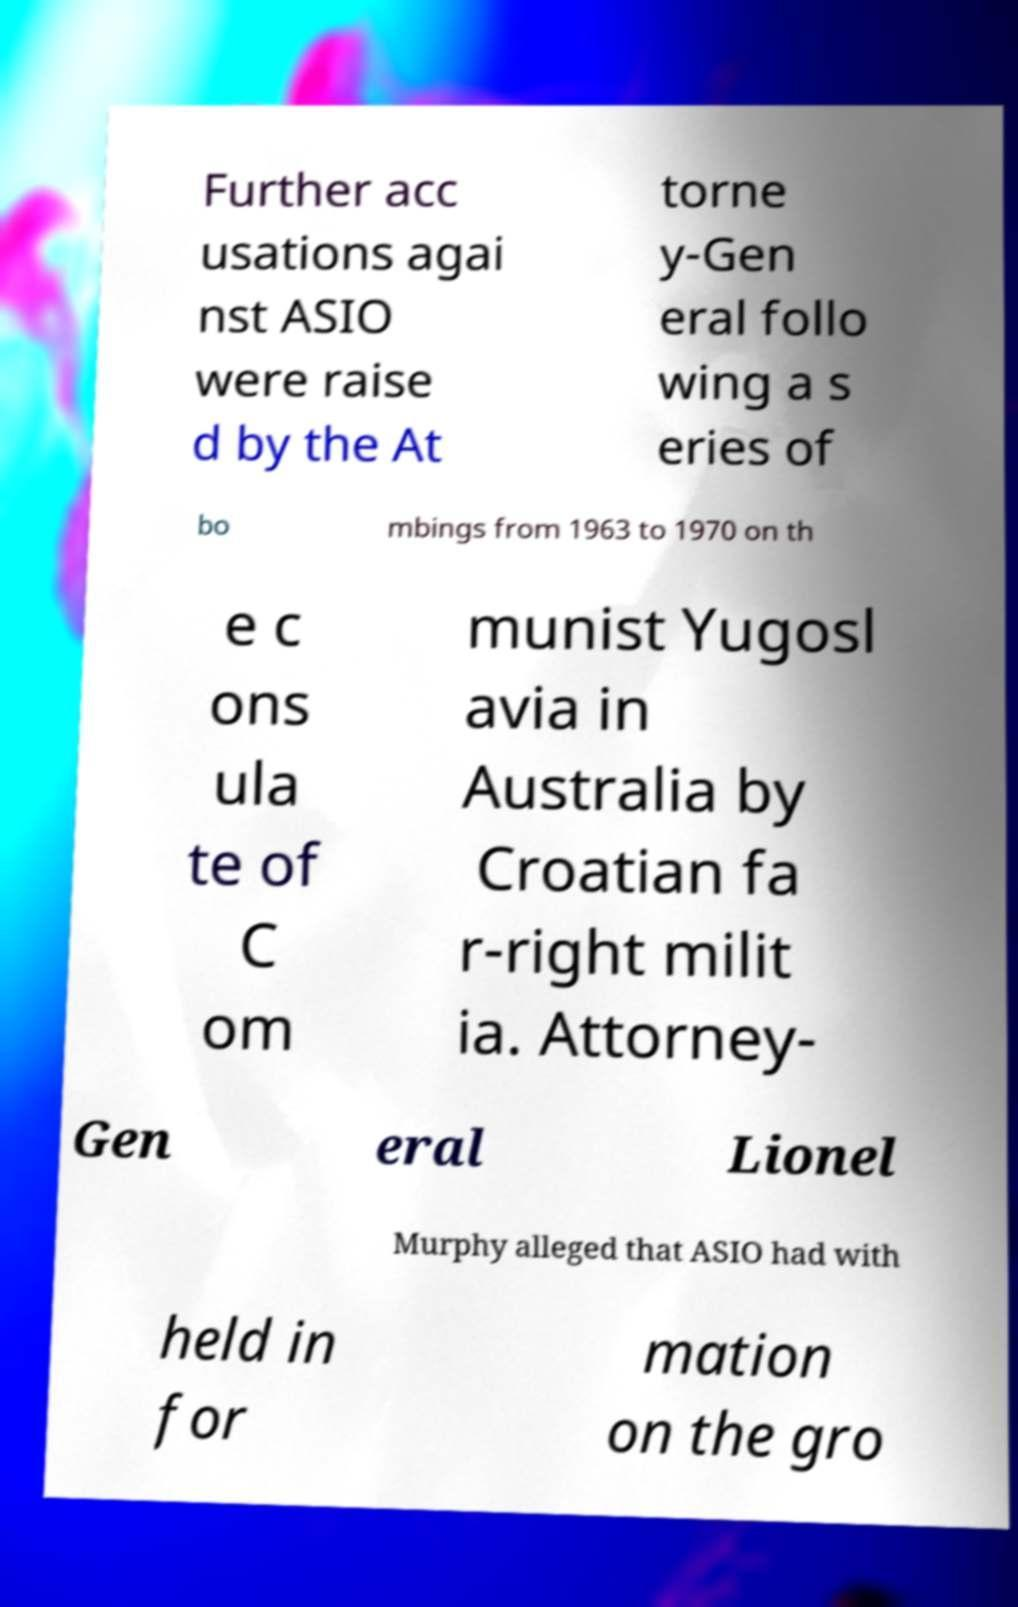I need the written content from this picture converted into text. Can you do that? Further acc usations agai nst ASIO were raise d by the At torne y-Gen eral follo wing a s eries of bo mbings from 1963 to 1970 on th e c ons ula te of C om munist Yugosl avia in Australia by Croatian fa r-right milit ia. Attorney- Gen eral Lionel Murphy alleged that ASIO had with held in for mation on the gro 